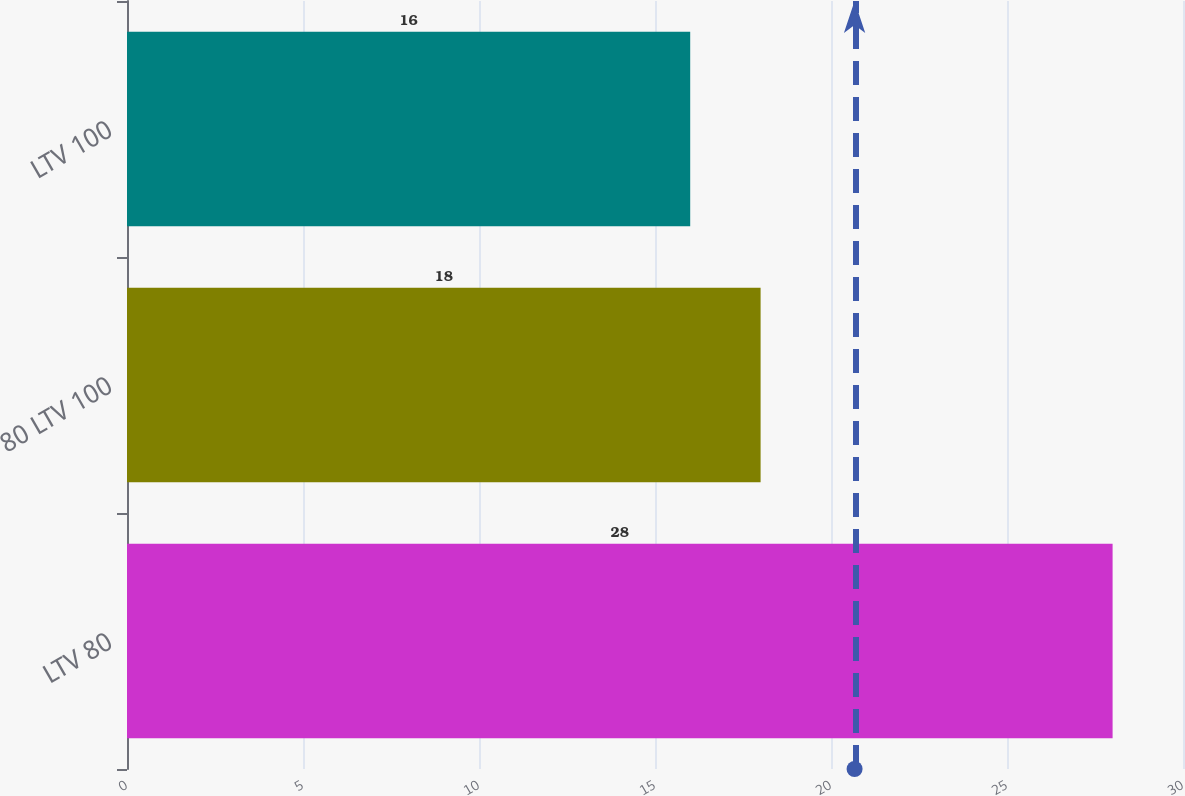Convert chart. <chart><loc_0><loc_0><loc_500><loc_500><bar_chart><fcel>LTV 80<fcel>80 LTV 100<fcel>LTV 100<nl><fcel>28<fcel>18<fcel>16<nl></chart> 